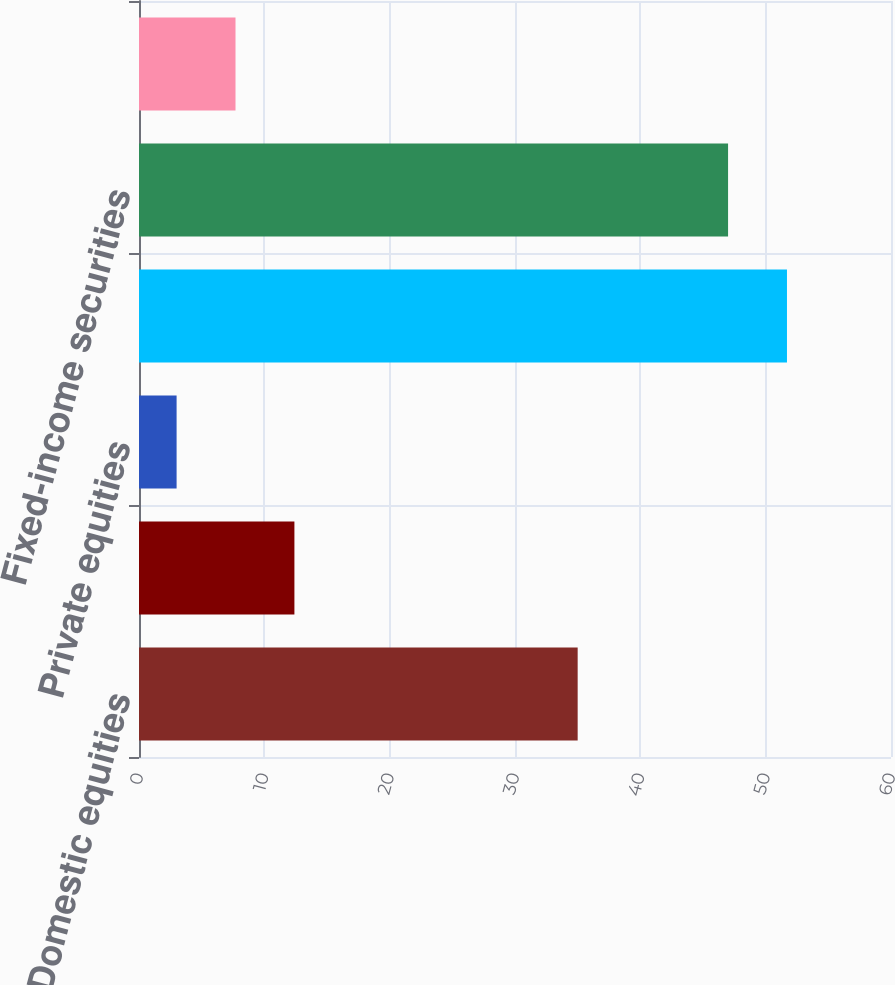Convert chart to OTSL. <chart><loc_0><loc_0><loc_500><loc_500><bar_chart><fcel>Domestic equities<fcel>International equities<fcel>Private equities<fcel>Total equities<fcel>Fixed-income securities<fcel>Cash and other<nl><fcel>35<fcel>12.4<fcel>3<fcel>51.7<fcel>47<fcel>7.7<nl></chart> 